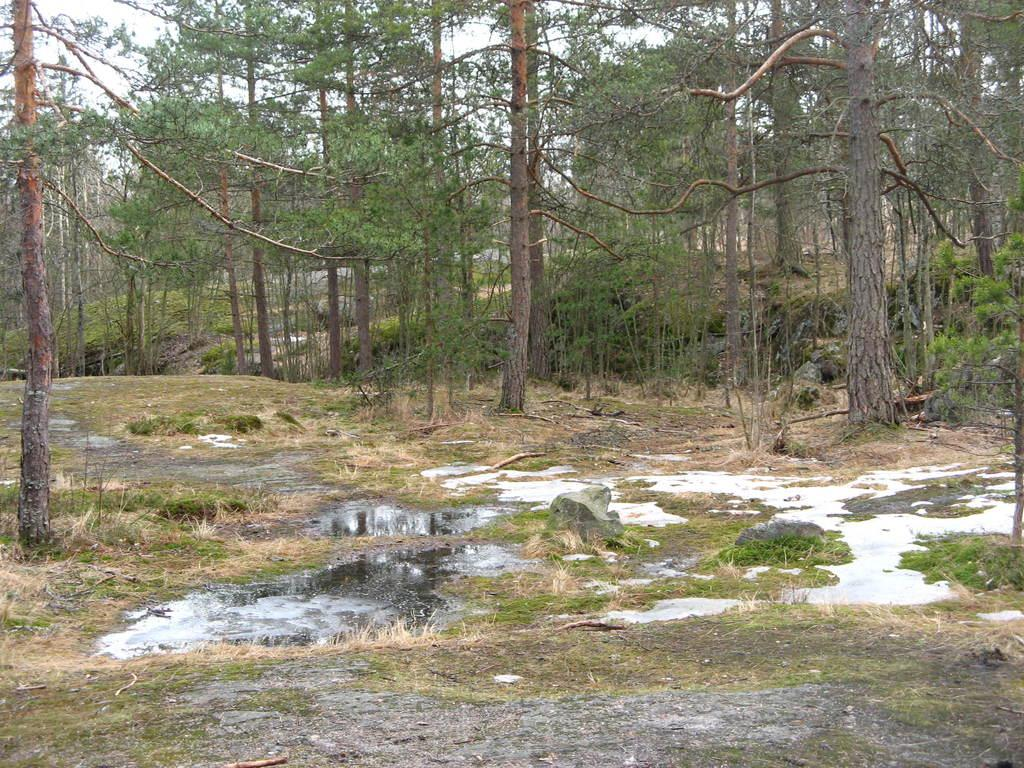What is covering the ground in the image? There is water on the ground in the image. What can be seen in the distance in the image? There are trees in the background of the image. Is there any snow visible in the image? No, there is no snow present in the image; it features water on the ground and trees in the background. 